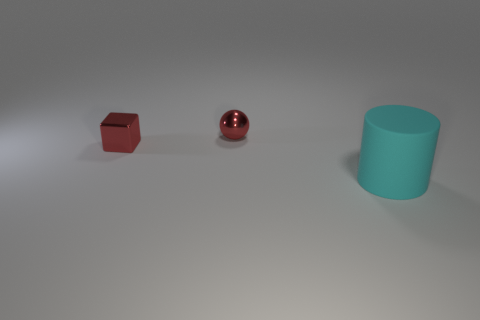Is there any other thing that has the same shape as the large matte thing?
Your answer should be compact. No. Are the big cyan cylinder and the red thing on the right side of the tiny red shiny cube made of the same material?
Provide a short and direct response. No. What color is the tiny metallic object on the left side of the tiny red ball behind the small metal thing that is to the left of the ball?
Your response must be concise. Red. Is there anything else that is the same size as the matte cylinder?
Ensure brevity in your answer.  No. There is a sphere; is it the same color as the small object that is in front of the tiny metal ball?
Keep it short and to the point. Yes. What color is the small shiny block?
Provide a succinct answer. Red. There is a small red thing in front of the tiny sphere that is right of the red thing that is to the left of the small red metallic ball; what shape is it?
Keep it short and to the point. Cube. How many other things are there of the same color as the small sphere?
Offer a terse response. 1. Is the number of large cyan rubber objects that are left of the rubber cylinder greater than the number of red shiny spheres that are right of the red sphere?
Your response must be concise. No. Are there any red metallic cubes right of the metallic cube?
Provide a succinct answer. No. 